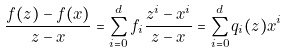Convert formula to latex. <formula><loc_0><loc_0><loc_500><loc_500>\frac { f ( z ) - f ( x ) } { z - x } = \sum _ { i = 0 } ^ { d } f _ { i } \frac { z ^ { i } - x ^ { i } } { z - x } = \sum _ { i = 0 } ^ { d } q _ { i } ( z ) x ^ { i }</formula> 